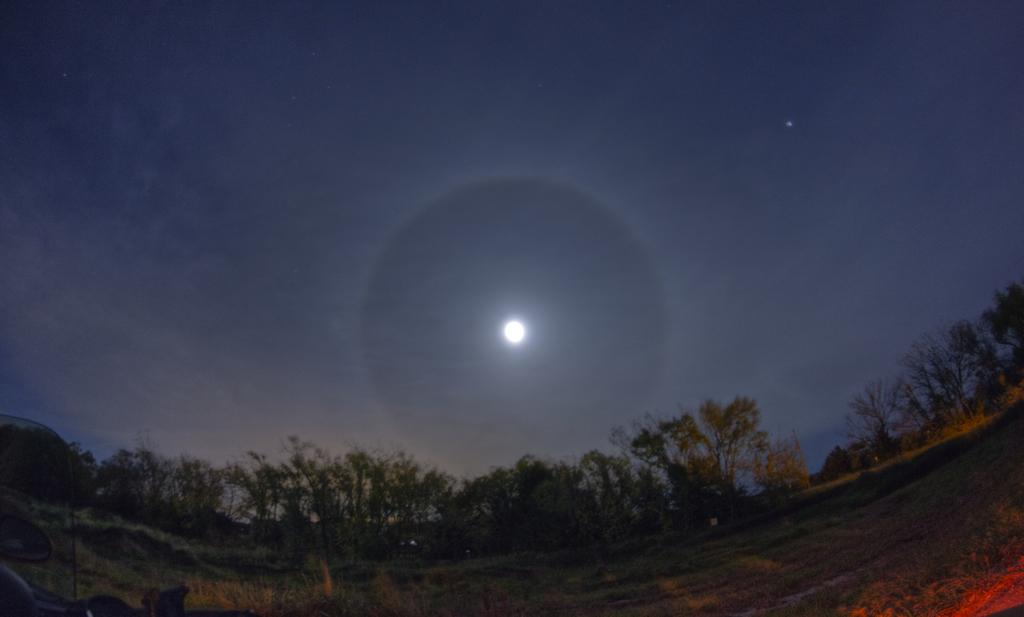What type of terrain is visible in the image? There is a land visible in the image. What can be seen in the background of the image? There are trees in the background of the image. What part of the natural environment is visible in the image? The sky is visible in the image. What celestial body can be seen in the sky? There is a moon in the sky. What type of guitar can be seen leaning against the trees in the image? There is no guitar present in the image; it only features land, trees, sky, and the moon. 